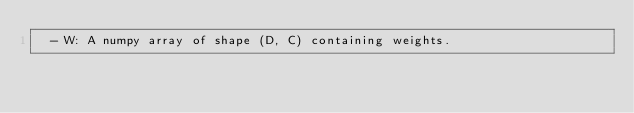Convert code to text. <code><loc_0><loc_0><loc_500><loc_500><_Python_>  - W: A numpy array of shape (D, C) containing weights.</code> 